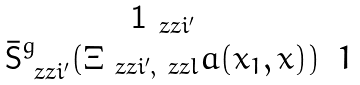Convert formula to latex. <formula><loc_0><loc_0><loc_500><loc_500>\begin{matrix} \mathbf 1 _ { \ z z i ^ { \prime } } & \\ \bar { \mathsf S } ^ { g } _ { \ z z i ^ { \prime } } ( \Xi _ { \ z z i ^ { \prime } , \ z z l } a ( x _ { 1 } , x ) ) & 1 \end{matrix}</formula> 